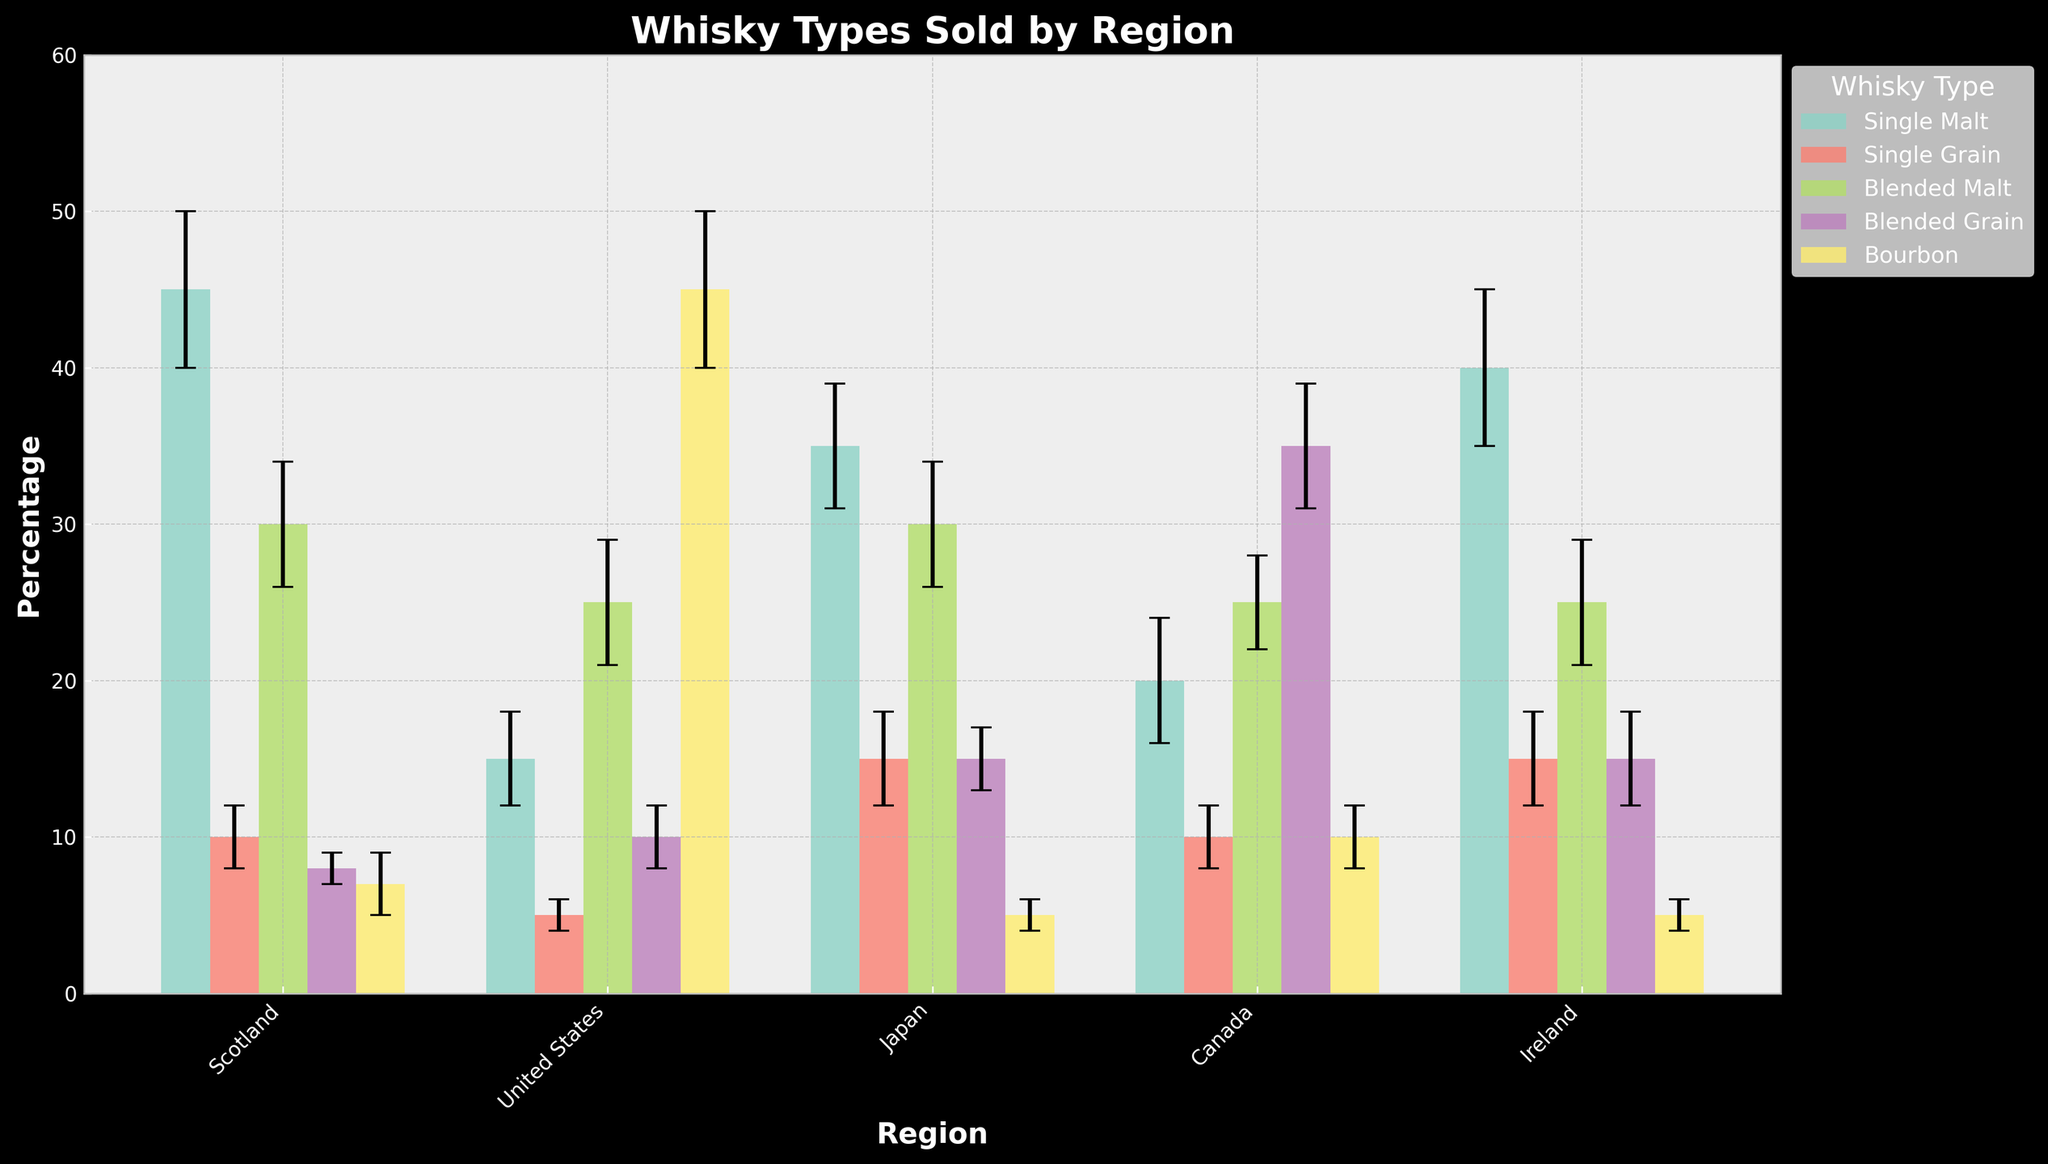What's the title of the figure? Look at the top of the figure; the title is usually placed here in bold text.
Answer: Whisky Types Sold by Region Which whisky type has the highest percentage in Scotland? Look at the bars representing different whisky types in the Scotland region. Identify the bar that reaches the highest value.
Answer: Single Malt What is the range of percentages for Blended Grain whisky types across all regions? To find the range, look at the highest and lowest percentage values for Blended Grain whiskies in all regions and subtract the lowest from the highest.
Answer: 35 - 8 = 27 Which region has the greatest variability in Single Malt sales? Variability can be assessed by the height of the error bars. Look at the error bars for Single Malt whisky in each region. The region with the longest error bars has the highest variability.
Answer: Ireland Compare the sales of Single Grain in Scotland and Canada. Are they equal? Check the heights of the bars representing Single Grain whisky in the Scotland and Canada regions. Compare the values.
Answer: Yes, they are equal Which region has the lowest percentage of Bourbon sales? Look at the bar heights for Bourbon in all regions and identify the lowest one.
Answer: Japan Calculate the average percentage of Blended Malt whisky sold across all regions. Add the percentages of Blended Malt for all regions and divide by the number of regions: (30+25+30+25+25) / 5.
Answer: 27 Is there any whisky type that dominates the market in the United States? Identify if any whisky type has a significantly higher percentage compared to others in the United States region.
Answer: Yes, Bourbon Which region shows the most diverse range of whisky types in terms of percentage sold? Look at the spread of percentages across all whisky types for each region and compare to identify the most diverse (widest spread) region.
Answer: Canada 